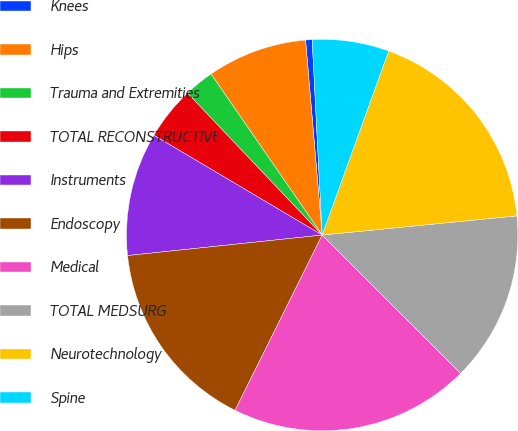<chart> <loc_0><loc_0><loc_500><loc_500><pie_chart><fcel>Knees<fcel>Hips<fcel>Trauma and Extremities<fcel>TOTAL RECONSTRUCTIVE<fcel>Instruments<fcel>Endoscopy<fcel>Medical<fcel>TOTAL MEDSURG<fcel>Neurotechnology<fcel>Spine<nl><fcel>0.54%<fcel>8.26%<fcel>2.47%<fcel>4.4%<fcel>10.19%<fcel>15.99%<fcel>19.85%<fcel>14.06%<fcel>17.92%<fcel>6.33%<nl></chart> 